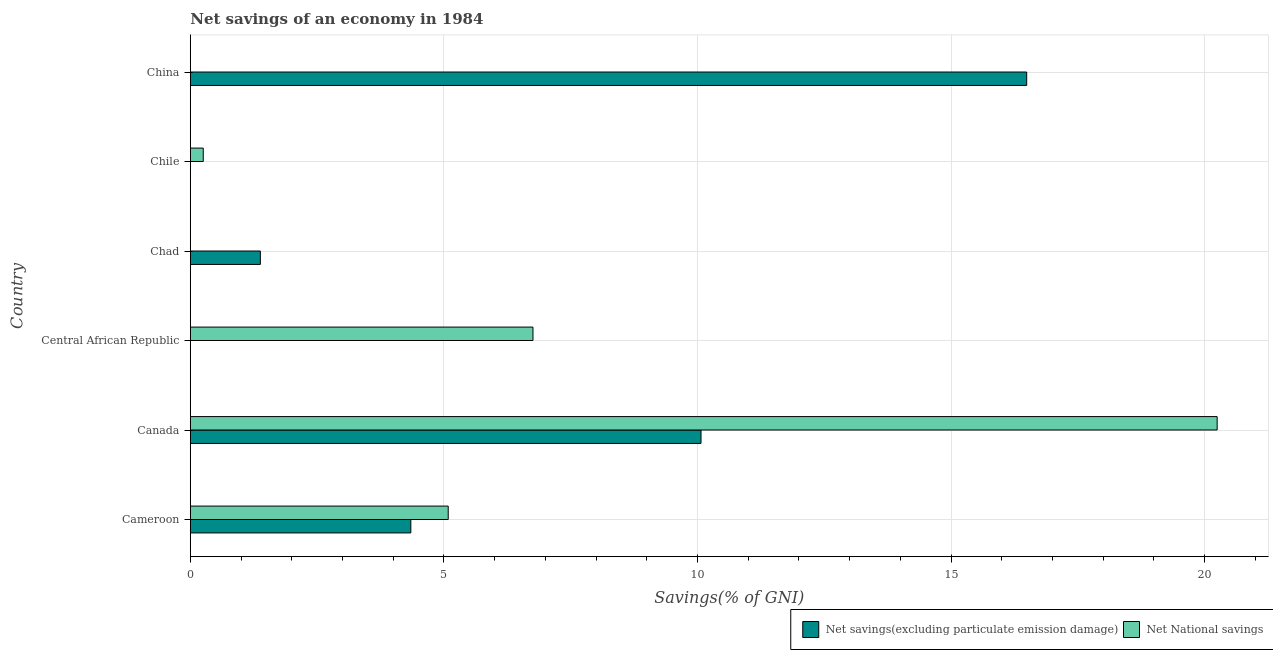How many different coloured bars are there?
Offer a terse response. 2. Are the number of bars on each tick of the Y-axis equal?
Ensure brevity in your answer.  No. How many bars are there on the 2nd tick from the top?
Provide a succinct answer. 1. What is the label of the 4th group of bars from the top?
Provide a succinct answer. Central African Republic. What is the net national savings in Chile?
Your answer should be very brief. 0.26. Across all countries, what is the maximum net national savings?
Keep it short and to the point. 20.25. Across all countries, what is the minimum net savings(excluding particulate emission damage)?
Ensure brevity in your answer.  0. In which country was the net national savings maximum?
Ensure brevity in your answer.  Canada. What is the total net savings(excluding particulate emission damage) in the graph?
Ensure brevity in your answer.  32.29. What is the difference between the net national savings in Cameroon and that in Central African Republic?
Ensure brevity in your answer.  -1.67. What is the difference between the net national savings in Canada and the net savings(excluding particulate emission damage) in Chile?
Your answer should be very brief. 20.25. What is the average net savings(excluding particulate emission damage) per country?
Your answer should be very brief. 5.38. What is the difference between the net savings(excluding particulate emission damage) and net national savings in Cameroon?
Provide a short and direct response. -0.74. What is the ratio of the net national savings in Cameroon to that in Central African Republic?
Provide a short and direct response. 0.75. What is the difference between the highest and the second highest net national savings?
Offer a very short reply. 13.49. What is the difference between the highest and the lowest net national savings?
Provide a short and direct response. 20.25. Is the sum of the net national savings in Cameroon and Chile greater than the maximum net savings(excluding particulate emission damage) across all countries?
Provide a succinct answer. No. How many countries are there in the graph?
Ensure brevity in your answer.  6. What is the difference between two consecutive major ticks on the X-axis?
Provide a succinct answer. 5. Are the values on the major ticks of X-axis written in scientific E-notation?
Offer a terse response. No. Does the graph contain grids?
Offer a very short reply. Yes. What is the title of the graph?
Provide a succinct answer. Net savings of an economy in 1984. What is the label or title of the X-axis?
Offer a terse response. Savings(% of GNI). What is the label or title of the Y-axis?
Ensure brevity in your answer.  Country. What is the Savings(% of GNI) of Net savings(excluding particulate emission damage) in Cameroon?
Your response must be concise. 4.35. What is the Savings(% of GNI) of Net National savings in Cameroon?
Offer a very short reply. 5.09. What is the Savings(% of GNI) in Net savings(excluding particulate emission damage) in Canada?
Keep it short and to the point. 10.07. What is the Savings(% of GNI) of Net National savings in Canada?
Give a very brief answer. 20.25. What is the Savings(% of GNI) in Net savings(excluding particulate emission damage) in Central African Republic?
Make the answer very short. 0. What is the Savings(% of GNI) of Net National savings in Central African Republic?
Ensure brevity in your answer.  6.76. What is the Savings(% of GNI) in Net savings(excluding particulate emission damage) in Chad?
Give a very brief answer. 1.38. What is the Savings(% of GNI) in Net National savings in Chad?
Ensure brevity in your answer.  0. What is the Savings(% of GNI) in Net savings(excluding particulate emission damage) in Chile?
Provide a succinct answer. 0. What is the Savings(% of GNI) in Net National savings in Chile?
Provide a succinct answer. 0.26. What is the Savings(% of GNI) in Net savings(excluding particulate emission damage) in China?
Your response must be concise. 16.49. Across all countries, what is the maximum Savings(% of GNI) in Net savings(excluding particulate emission damage)?
Ensure brevity in your answer.  16.49. Across all countries, what is the maximum Savings(% of GNI) in Net National savings?
Offer a very short reply. 20.25. Across all countries, what is the minimum Savings(% of GNI) of Net National savings?
Ensure brevity in your answer.  0. What is the total Savings(% of GNI) of Net savings(excluding particulate emission damage) in the graph?
Provide a succinct answer. 32.29. What is the total Savings(% of GNI) of Net National savings in the graph?
Offer a terse response. 32.35. What is the difference between the Savings(% of GNI) in Net savings(excluding particulate emission damage) in Cameroon and that in Canada?
Give a very brief answer. -5.72. What is the difference between the Savings(% of GNI) in Net National savings in Cameroon and that in Canada?
Offer a very short reply. -15.16. What is the difference between the Savings(% of GNI) of Net National savings in Cameroon and that in Central African Republic?
Give a very brief answer. -1.67. What is the difference between the Savings(% of GNI) of Net savings(excluding particulate emission damage) in Cameroon and that in Chad?
Provide a succinct answer. 2.97. What is the difference between the Savings(% of GNI) in Net National savings in Cameroon and that in Chile?
Offer a very short reply. 4.83. What is the difference between the Savings(% of GNI) of Net savings(excluding particulate emission damage) in Cameroon and that in China?
Give a very brief answer. -12.14. What is the difference between the Savings(% of GNI) in Net National savings in Canada and that in Central African Republic?
Make the answer very short. 13.49. What is the difference between the Savings(% of GNI) of Net savings(excluding particulate emission damage) in Canada and that in Chad?
Offer a very short reply. 8.69. What is the difference between the Savings(% of GNI) in Net National savings in Canada and that in Chile?
Your answer should be compact. 19.99. What is the difference between the Savings(% of GNI) of Net savings(excluding particulate emission damage) in Canada and that in China?
Make the answer very short. -6.42. What is the difference between the Savings(% of GNI) in Net National savings in Central African Republic and that in Chile?
Offer a very short reply. 6.5. What is the difference between the Savings(% of GNI) of Net savings(excluding particulate emission damage) in Chad and that in China?
Offer a terse response. -15.11. What is the difference between the Savings(% of GNI) in Net savings(excluding particulate emission damage) in Cameroon and the Savings(% of GNI) in Net National savings in Canada?
Your answer should be very brief. -15.9. What is the difference between the Savings(% of GNI) of Net savings(excluding particulate emission damage) in Cameroon and the Savings(% of GNI) of Net National savings in Central African Republic?
Provide a succinct answer. -2.41. What is the difference between the Savings(% of GNI) in Net savings(excluding particulate emission damage) in Cameroon and the Savings(% of GNI) in Net National savings in Chile?
Your response must be concise. 4.09. What is the difference between the Savings(% of GNI) of Net savings(excluding particulate emission damage) in Canada and the Savings(% of GNI) of Net National savings in Central African Republic?
Keep it short and to the point. 3.31. What is the difference between the Savings(% of GNI) in Net savings(excluding particulate emission damage) in Canada and the Savings(% of GNI) in Net National savings in Chile?
Offer a very short reply. 9.82. What is the difference between the Savings(% of GNI) in Net savings(excluding particulate emission damage) in Chad and the Savings(% of GNI) in Net National savings in Chile?
Provide a succinct answer. 1.13. What is the average Savings(% of GNI) in Net savings(excluding particulate emission damage) per country?
Your response must be concise. 5.38. What is the average Savings(% of GNI) in Net National savings per country?
Offer a very short reply. 5.39. What is the difference between the Savings(% of GNI) of Net savings(excluding particulate emission damage) and Savings(% of GNI) of Net National savings in Cameroon?
Offer a very short reply. -0.74. What is the difference between the Savings(% of GNI) of Net savings(excluding particulate emission damage) and Savings(% of GNI) of Net National savings in Canada?
Your answer should be very brief. -10.18. What is the ratio of the Savings(% of GNI) of Net savings(excluding particulate emission damage) in Cameroon to that in Canada?
Your answer should be very brief. 0.43. What is the ratio of the Savings(% of GNI) in Net National savings in Cameroon to that in Canada?
Keep it short and to the point. 0.25. What is the ratio of the Savings(% of GNI) in Net National savings in Cameroon to that in Central African Republic?
Ensure brevity in your answer.  0.75. What is the ratio of the Savings(% of GNI) of Net savings(excluding particulate emission damage) in Cameroon to that in Chad?
Ensure brevity in your answer.  3.15. What is the ratio of the Savings(% of GNI) in Net National savings in Cameroon to that in Chile?
Offer a very short reply. 19.91. What is the ratio of the Savings(% of GNI) of Net savings(excluding particulate emission damage) in Cameroon to that in China?
Your response must be concise. 0.26. What is the ratio of the Savings(% of GNI) of Net National savings in Canada to that in Central African Republic?
Your response must be concise. 3. What is the ratio of the Savings(% of GNI) of Net savings(excluding particulate emission damage) in Canada to that in Chad?
Ensure brevity in your answer.  7.29. What is the ratio of the Savings(% of GNI) of Net National savings in Canada to that in Chile?
Keep it short and to the point. 79.27. What is the ratio of the Savings(% of GNI) in Net savings(excluding particulate emission damage) in Canada to that in China?
Keep it short and to the point. 0.61. What is the ratio of the Savings(% of GNI) of Net National savings in Central African Republic to that in Chile?
Keep it short and to the point. 26.45. What is the ratio of the Savings(% of GNI) of Net savings(excluding particulate emission damage) in Chad to that in China?
Keep it short and to the point. 0.08. What is the difference between the highest and the second highest Savings(% of GNI) of Net savings(excluding particulate emission damage)?
Offer a terse response. 6.42. What is the difference between the highest and the second highest Savings(% of GNI) in Net National savings?
Ensure brevity in your answer.  13.49. What is the difference between the highest and the lowest Savings(% of GNI) in Net savings(excluding particulate emission damage)?
Make the answer very short. 16.49. What is the difference between the highest and the lowest Savings(% of GNI) of Net National savings?
Make the answer very short. 20.25. 